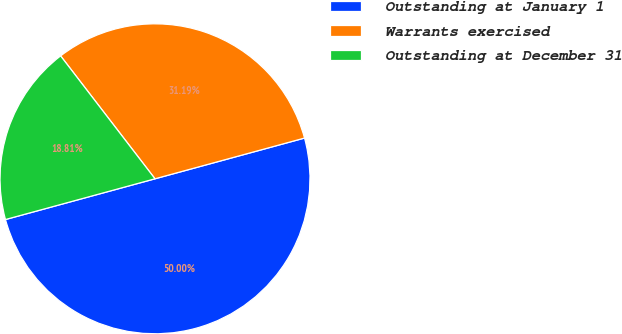Convert chart. <chart><loc_0><loc_0><loc_500><loc_500><pie_chart><fcel>Outstanding at January 1<fcel>Warrants exercised<fcel>Outstanding at December 31<nl><fcel>50.0%<fcel>31.19%<fcel>18.81%<nl></chart> 